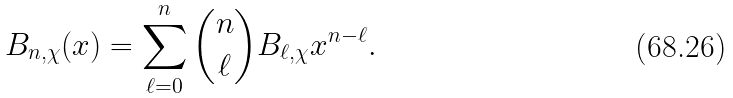Convert formula to latex. <formula><loc_0><loc_0><loc_500><loc_500>B _ { n , \chi } ( x ) = \sum _ { \ell = 0 } ^ { n } \binom { n } { \ell } B _ { \ell , \chi } x ^ { n - \ell } .</formula> 